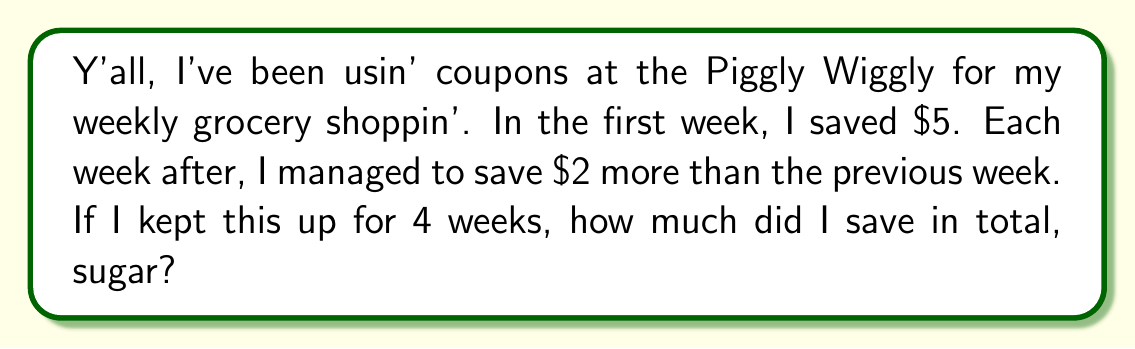Can you solve this math problem? Let's break this down step-by-step, honey:

1) We're dealin' with an arithmetic sequence here. The first term (a₁) is $5, and the common difference (d) is $2.

2) We can write out the savings for each week:
   Week 1: $5
   Week 2: $5 + $2 = $7
   Week 3: $7 + $2 = $9
   Week 4: $9 + $2 = $11

3) To find the total savings, we need to sum these up. In mathematical terms, we're lookin' for:

   $S_n = \frac{n}{2}(a_1 + a_n)$

   Where $S_n$ is the sum, $n$ is the number of terms, $a_1$ is the first term, and $a_n$ is the last term.

4) We know:
   $n = 4$ (4 weeks)
   $a_1 = 5$ (first week's savings)
   $a_n = a_4 = 11$ (last week's savings)

5) Let's plug these into our formula:

   $S_4 = \frac{4}{2}(5 + 11)$

6) Now, let's do the arithmetic:

   $S_4 = 2(16) = 32$

So, sugar, over the course of 4 weeks, you saved a total of $32 on your grocery shoppin'.
Answer: $32 